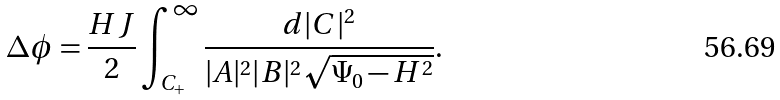Convert formula to latex. <formula><loc_0><loc_0><loc_500><loc_500>\Delta \phi = \frac { H J } { 2 } \int ^ { \infty } _ { C _ { + } } \frac { d | C | ^ { 2 } } { | A | ^ { 2 } | B | ^ { 2 } \sqrt { \Psi _ { 0 } - H ^ { 2 } } } .</formula> 